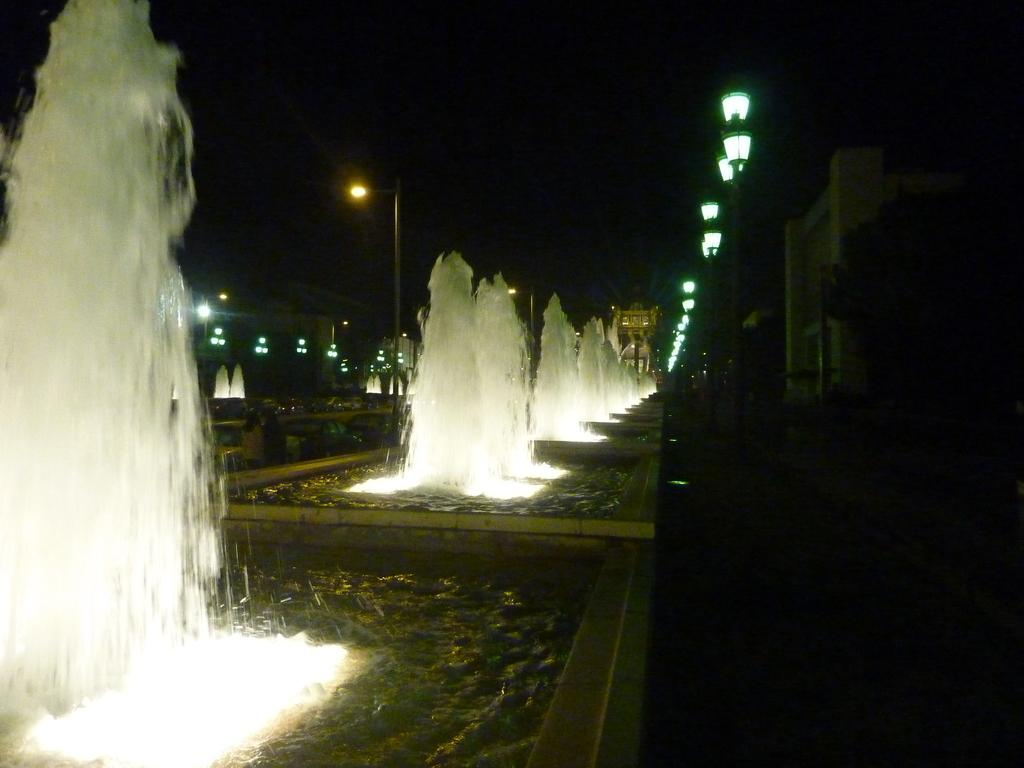What type of structures can be seen in the image? There are fountains in the image. What type of lighting is present in the image? There are street lights in the image. What are the people in the image doing? There are people walking on a walkway in the image. Where is the heart located in the image? There is no heart present in the image. What type of friction can be observed between the people walking on the walkway? The image does not provide information about the friction between the people walking on the walkway. 